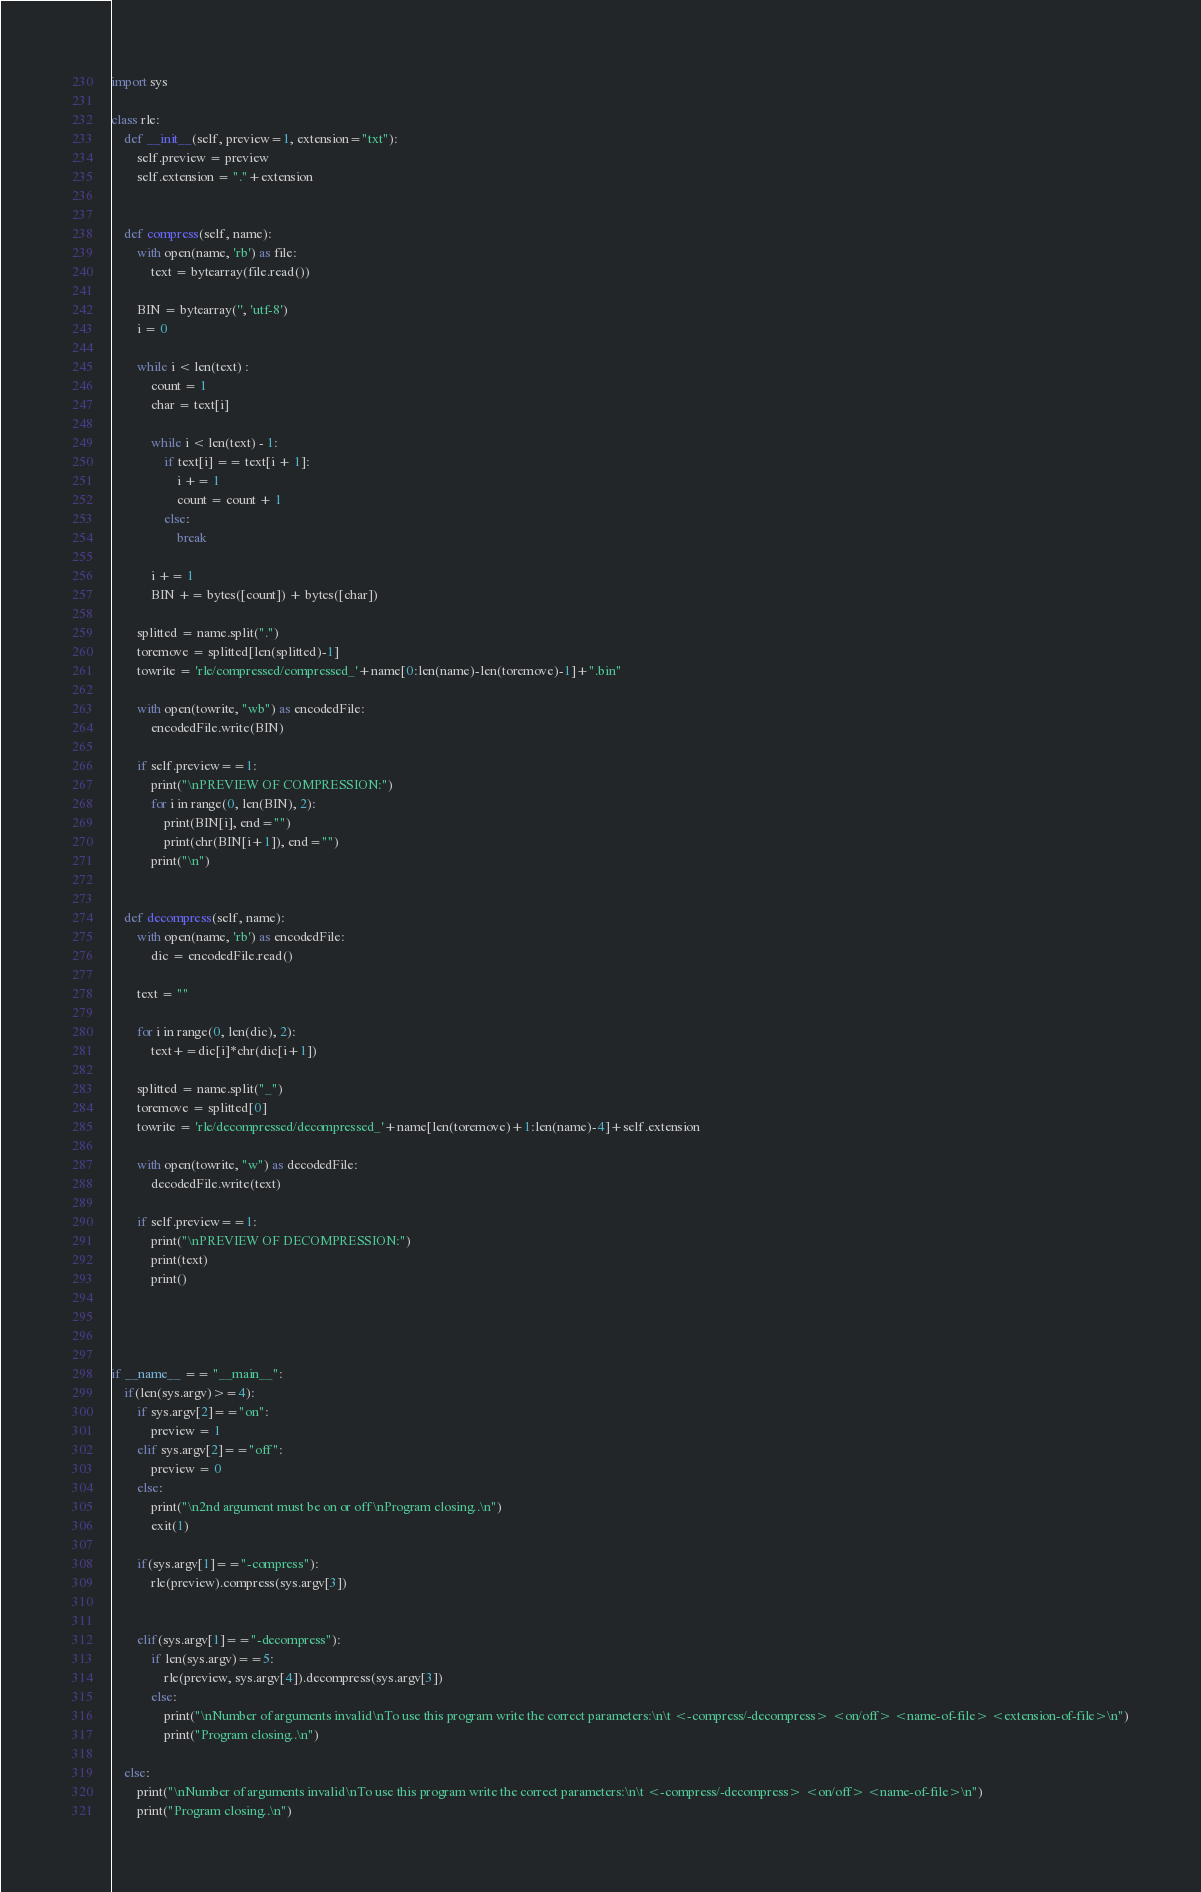Convert code to text. <code><loc_0><loc_0><loc_500><loc_500><_Python_>import sys

class rle:
    def __init__(self, preview=1, extension="txt"):
        self.preview = preview
        self.extension = "."+extension


    def compress(self, name):
        with open(name, 'rb') as file:
            text = bytearray(file.read())

        BIN = bytearray('', 'utf-8')
        i = 0

        while i < len(text) :
            count = 1
            char = text[i]

            while i < len(text) - 1:
                if text[i] == text[i + 1]:
                    i += 1
                    count = count + 1
                else:
                    break

            i += 1
            BIN += bytes([count]) + bytes([char])

        splitted = name.split(".")
        toremove = splitted[len(splitted)-1]
        towrite = 'rle/compressed/compressed_'+name[0:len(name)-len(toremove)-1]+".bin"
        
        with open(towrite, "wb") as encodedFile:
            encodedFile.write(BIN)

        if self.preview==1:
            print("\nPREVIEW OF COMPRESSION:")
            for i in range(0, len(BIN), 2):
                print(BIN[i], end="") 
                print(chr(BIN[i+1]), end="") 
            print("\n")


    def decompress(self, name):
        with open(name, 'rb') as encodedFile:
            dic = encodedFile.read()

        text = ""

        for i in range(0, len(dic), 2):
            text+=dic[i]*chr(dic[i+1])

        splitted = name.split("_")
        toremove = splitted[0]
        towrite = 'rle/decompressed/decompressed_'+name[len(toremove)+1:len(name)-4]+self.extension

        with open(towrite, "w") as decodedFile:
            decodedFile.write(text)

        if self.preview==1:
            print("\nPREVIEW OF DECOMPRESSION:")
            print(text)
            print()




if __name__ == "__main__":
    if(len(sys.argv)>=4):
        if sys.argv[2]=="on":
            preview = 1
        elif sys.argv[2]=="off":
            preview = 0
        else:
            print("\n2nd argument must be on or off\nProgram closing..\n")
            exit(1)

        if(sys.argv[1]=="-compress"):
            rle(preview).compress(sys.argv[3])
            

        elif(sys.argv[1]=="-decompress"):
            if len(sys.argv)==5:  
                rle(preview, sys.argv[4]).decompress(sys.argv[3])
            else:
                print("\nNumber of arguments invalid\nTo use this program write the correct parameters:\n\t <-compress/-decompress> <on/off> <name-of-file> <extension-of-file>\n")
                print("Program closing..\n")

    else:
        print("\nNumber of arguments invalid\nTo use this program write the correct parameters:\n\t <-compress/-decompress> <on/off> <name-of-file>\n")
        print("Program closing..\n")</code> 